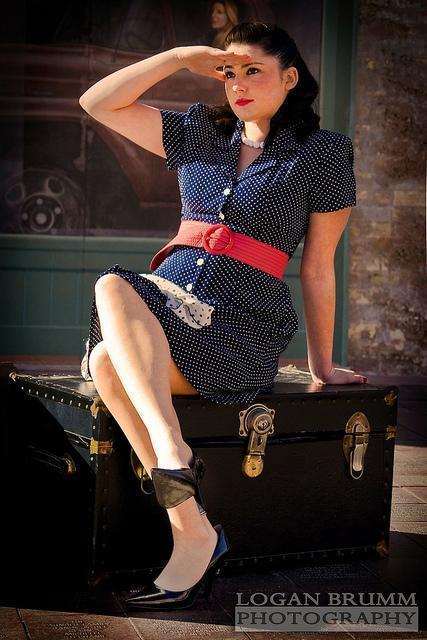What is usually held in the item being sat on here?
From the following four choices, select the correct answer to address the question.
Options: Dogs, coffee, bibles, clothing. Clothing. 